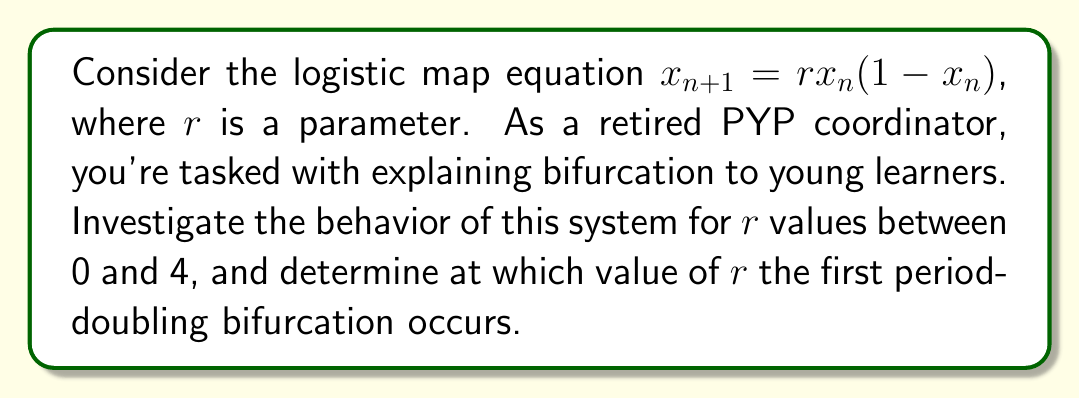Can you answer this question? 1) The logistic map is a simple nonlinear equation that can exhibit complex behavior:
   $$x_{n+1} = rx_n(1-x_n)$$

2) For small values of $r$ (0 < $r$ < 1), the system converges to 0.

3) As $r$ increases:
   - For 1 < $r$ < 3, the system converges to a single non-zero value.
   - At $r$ = 3, the system undergoes its first bifurcation.

4) To find the first bifurcation point:
   - Set $x_{n+1} = x_n = x^*$ (fixed point)
   - Solve: $x^* = rx^*(1-x^*)$
   - This gives: $x^* = 0$ or $x^* = 1 - \frac{1}{r}$

5) The stability of the non-zero fixed point changes when:
   $$\left|\frac{d}{dx}(rx(1-x))\right|_{x=x^*} = |-2rx^* + r| = 1$$

6) Substituting $x^* = 1 - \frac{1}{r}$:
   $$|-2r(1-\frac{1}{r}) + r| = |-2r+2+r| = |r-2| = 1$$

7) Solving this equation:
   $r - 2 = 1$ or $r - 2 = -1$
   $r = 3$ or $r = 1$

8) Since we're looking for the first bifurcation after stability, $r = 3$ is our answer.
Answer: $r = 3$ 